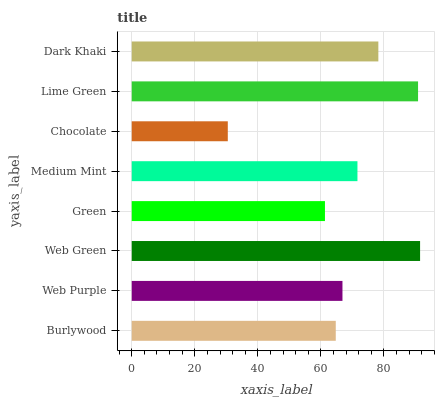Is Chocolate the minimum?
Answer yes or no. Yes. Is Web Green the maximum?
Answer yes or no. Yes. Is Web Purple the minimum?
Answer yes or no. No. Is Web Purple the maximum?
Answer yes or no. No. Is Web Purple greater than Burlywood?
Answer yes or no. Yes. Is Burlywood less than Web Purple?
Answer yes or no. Yes. Is Burlywood greater than Web Purple?
Answer yes or no. No. Is Web Purple less than Burlywood?
Answer yes or no. No. Is Medium Mint the high median?
Answer yes or no. Yes. Is Web Purple the low median?
Answer yes or no. Yes. Is Lime Green the high median?
Answer yes or no. No. Is Lime Green the low median?
Answer yes or no. No. 